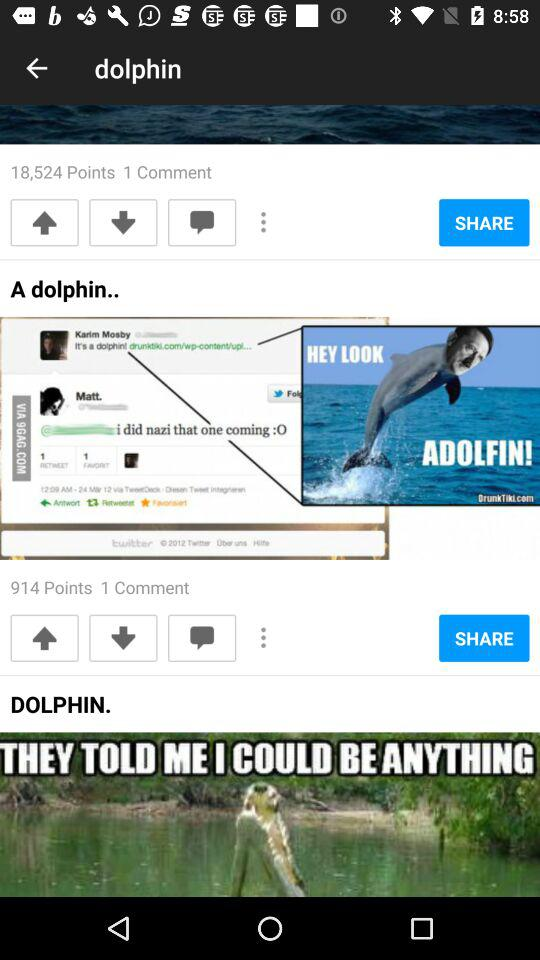How many comments are there for the post "A dolphin"? There is 1 comment for the post "A dolphin". 